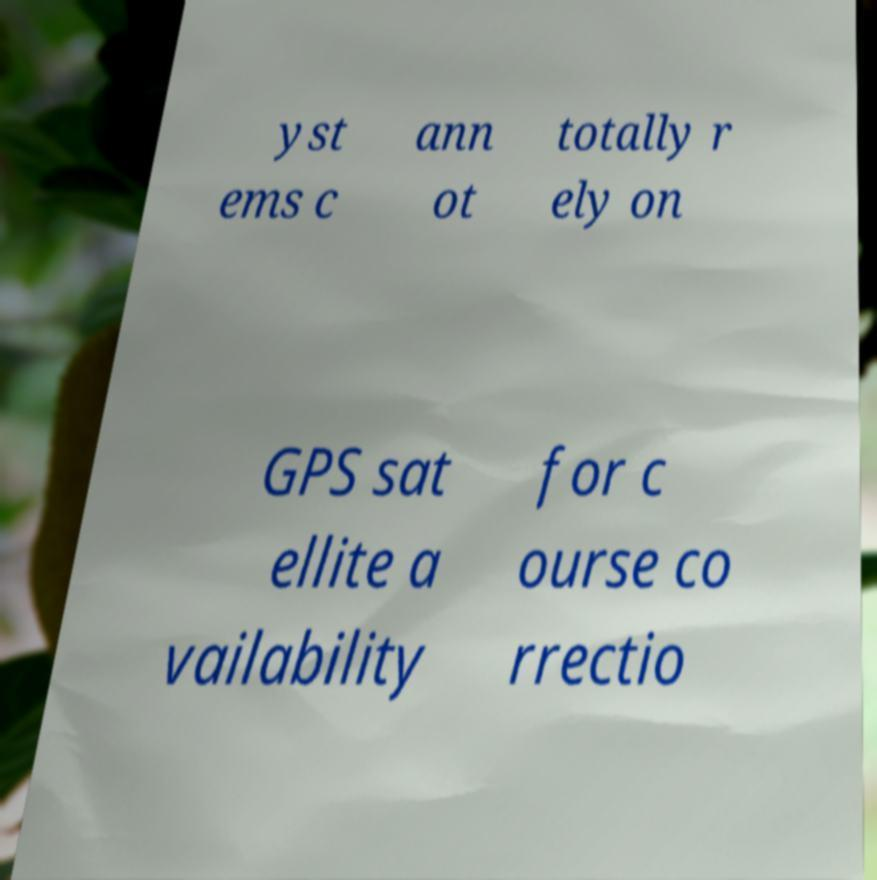Can you accurately transcribe the text from the provided image for me? yst ems c ann ot totally r ely on GPS sat ellite a vailability for c ourse co rrectio 